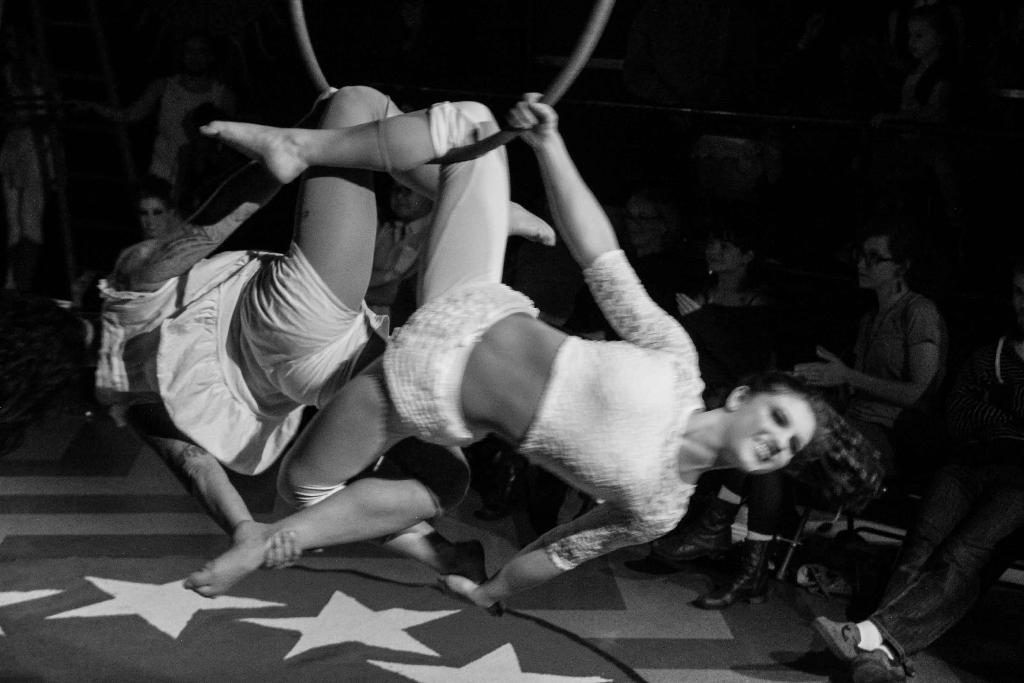What are the two persons in the foreground of the image doing? The two persons in the foreground of the image are performing stunts. Can you describe the people in the background of the image? There are many people watching the stunts in the background of the image. What type of insurance policy do the dolls in the image have? There are no dolls present in the image, so it is not possible to determine if they have any insurance policy. 